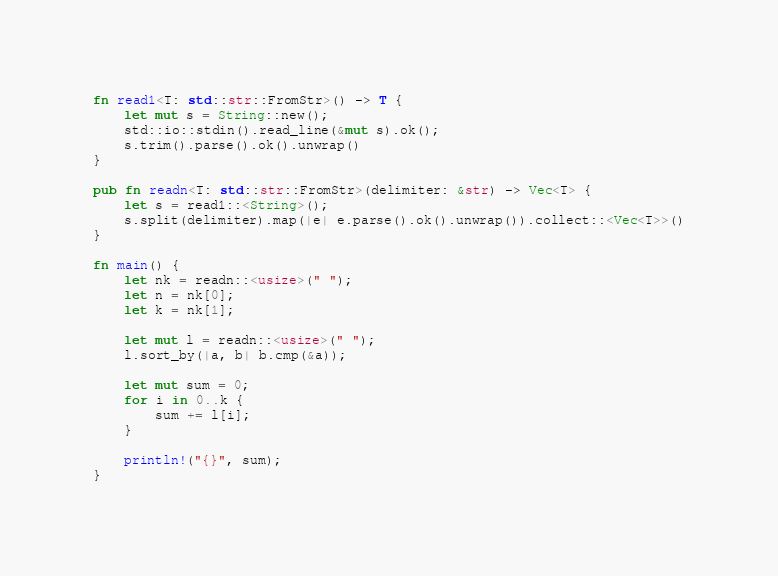Convert code to text. <code><loc_0><loc_0><loc_500><loc_500><_Rust_>fn read1<T: std::str::FromStr>() -> T {
    let mut s = String::new();
    std::io::stdin().read_line(&mut s).ok();
    s.trim().parse().ok().unwrap()
}

pub fn readn<T: std::str::FromStr>(delimiter: &str) -> Vec<T> {
    let s = read1::<String>();
    s.split(delimiter).map(|e| e.parse().ok().unwrap()).collect::<Vec<T>>()
}

fn main() {
    let nk = readn::<usize>(" ");
    let n = nk[0];
    let k = nk[1];

    let mut l = readn::<usize>(" ");
    l.sort_by(|a, b| b.cmp(&a));

    let mut sum = 0;
    for i in 0..k {
        sum += l[i];
    }

    println!("{}", sum);
}</code> 